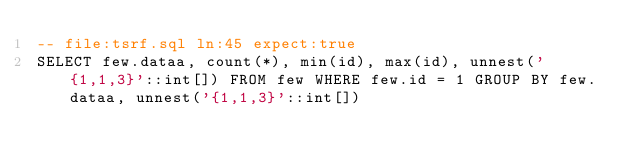<code> <loc_0><loc_0><loc_500><loc_500><_SQL_>-- file:tsrf.sql ln:45 expect:true
SELECT few.dataa, count(*), min(id), max(id), unnest('{1,1,3}'::int[]) FROM few WHERE few.id = 1 GROUP BY few.dataa, unnest('{1,1,3}'::int[])
</code> 